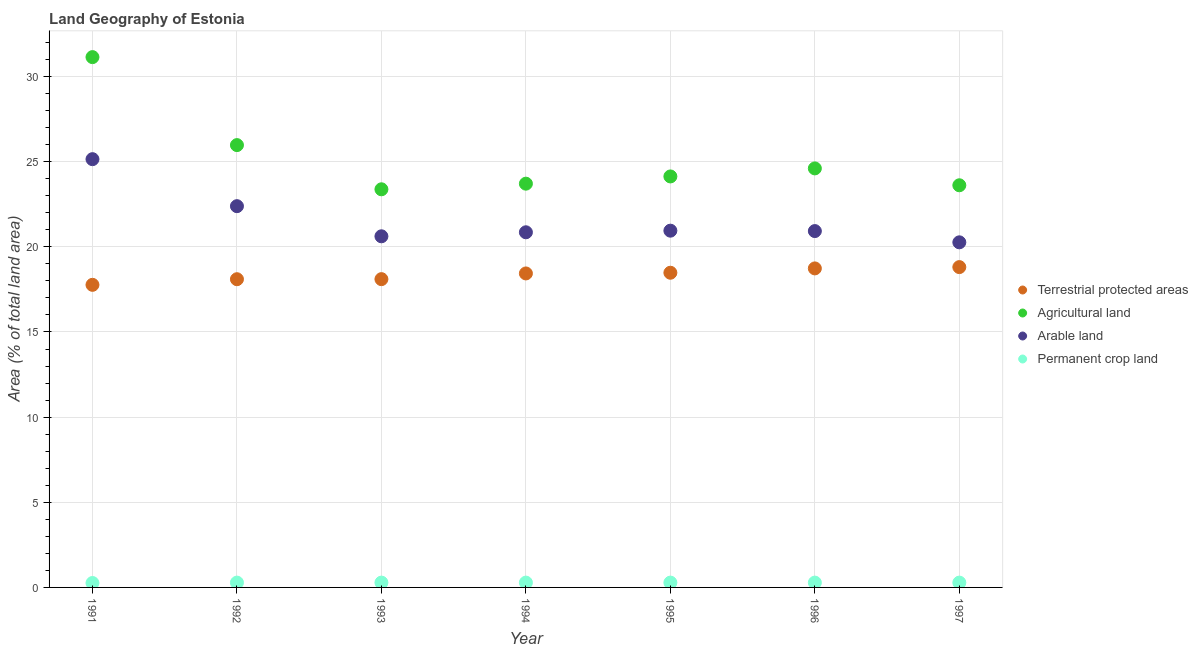What is the percentage of area under agricultural land in 1995?
Offer a very short reply. 24.13. Across all years, what is the maximum percentage of area under arable land?
Ensure brevity in your answer.  25.15. Across all years, what is the minimum percentage of area under agricultural land?
Offer a very short reply. 23.38. In which year was the percentage of area under arable land minimum?
Keep it short and to the point. 1997. What is the total percentage of area under permanent crop land in the graph?
Provide a succinct answer. 1.96. What is the difference between the percentage of land under terrestrial protection in 1993 and that in 1995?
Offer a terse response. -0.38. What is the difference between the percentage of area under permanent crop land in 1994 and the percentage of area under agricultural land in 1993?
Ensure brevity in your answer.  -23.1. What is the average percentage of area under permanent crop land per year?
Your response must be concise. 0.28. In the year 1991, what is the difference between the percentage of area under arable land and percentage of area under permanent crop land?
Offer a very short reply. 24.89. What is the ratio of the percentage of area under agricultural land in 1992 to that in 1993?
Ensure brevity in your answer.  1.11. Is the difference between the percentage of land under terrestrial protection in 1995 and 1997 greater than the difference between the percentage of area under agricultural land in 1995 and 1997?
Provide a short and direct response. No. What is the difference between the highest and the second highest percentage of land under terrestrial protection?
Offer a very short reply. 0.08. What is the difference between the highest and the lowest percentage of area under agricultural land?
Give a very brief answer. 7.76. In how many years, is the percentage of area under agricultural land greater than the average percentage of area under agricultural land taken over all years?
Keep it short and to the point. 2. Is the sum of the percentage of area under permanent crop land in 1992 and 1996 greater than the maximum percentage of area under agricultural land across all years?
Offer a terse response. No. How many years are there in the graph?
Your answer should be compact. 7. Are the values on the major ticks of Y-axis written in scientific E-notation?
Ensure brevity in your answer.  No. Does the graph contain any zero values?
Your answer should be very brief. No. Does the graph contain grids?
Give a very brief answer. Yes. How are the legend labels stacked?
Offer a very short reply. Vertical. What is the title of the graph?
Your response must be concise. Land Geography of Estonia. What is the label or title of the Y-axis?
Provide a succinct answer. Area (% of total land area). What is the Area (% of total land area) in Terrestrial protected areas in 1991?
Provide a short and direct response. 17.77. What is the Area (% of total land area) in Agricultural land in 1991?
Offer a very short reply. 31.14. What is the Area (% of total land area) in Arable land in 1991?
Your answer should be very brief. 25.15. What is the Area (% of total land area) of Permanent crop land in 1991?
Provide a succinct answer. 0.26. What is the Area (% of total land area) in Terrestrial protected areas in 1992?
Provide a succinct answer. 18.1. What is the Area (% of total land area) in Agricultural land in 1992?
Your response must be concise. 25.97. What is the Area (% of total land area) in Arable land in 1992?
Keep it short and to the point. 22.39. What is the Area (% of total land area) of Permanent crop land in 1992?
Provide a succinct answer. 0.28. What is the Area (% of total land area) in Terrestrial protected areas in 1993?
Your answer should be very brief. 18.1. What is the Area (% of total land area) of Agricultural land in 1993?
Make the answer very short. 23.38. What is the Area (% of total land area) of Arable land in 1993?
Provide a succinct answer. 20.62. What is the Area (% of total land area) in Permanent crop land in 1993?
Give a very brief answer. 0.28. What is the Area (% of total land area) in Terrestrial protected areas in 1994?
Give a very brief answer. 18.44. What is the Area (% of total land area) in Agricultural land in 1994?
Give a very brief answer. 23.71. What is the Area (% of total land area) in Arable land in 1994?
Your answer should be very brief. 20.85. What is the Area (% of total land area) of Permanent crop land in 1994?
Your answer should be compact. 0.28. What is the Area (% of total land area) of Terrestrial protected areas in 1995?
Offer a terse response. 18.48. What is the Area (% of total land area) of Agricultural land in 1995?
Your answer should be compact. 24.13. What is the Area (% of total land area) of Arable land in 1995?
Keep it short and to the point. 20.95. What is the Area (% of total land area) in Permanent crop land in 1995?
Offer a very short reply. 0.28. What is the Area (% of total land area) of Terrestrial protected areas in 1996?
Offer a very short reply. 18.73. What is the Area (% of total land area) of Agricultural land in 1996?
Provide a short and direct response. 24.6. What is the Area (% of total land area) in Arable land in 1996?
Your answer should be compact. 20.92. What is the Area (% of total land area) in Permanent crop land in 1996?
Your answer should be compact. 0.28. What is the Area (% of total land area) in Terrestrial protected areas in 1997?
Your answer should be compact. 18.81. What is the Area (% of total land area) of Agricultural land in 1997?
Provide a short and direct response. 23.61. What is the Area (% of total land area) of Arable land in 1997?
Offer a terse response. 20.26. What is the Area (% of total land area) in Permanent crop land in 1997?
Give a very brief answer. 0.28. Across all years, what is the maximum Area (% of total land area) in Terrestrial protected areas?
Give a very brief answer. 18.81. Across all years, what is the maximum Area (% of total land area) of Agricultural land?
Your response must be concise. 31.14. Across all years, what is the maximum Area (% of total land area) of Arable land?
Make the answer very short. 25.15. Across all years, what is the maximum Area (% of total land area) in Permanent crop land?
Your response must be concise. 0.28. Across all years, what is the minimum Area (% of total land area) of Terrestrial protected areas?
Give a very brief answer. 17.77. Across all years, what is the minimum Area (% of total land area) in Agricultural land?
Offer a very short reply. 23.38. Across all years, what is the minimum Area (% of total land area) in Arable land?
Keep it short and to the point. 20.26. Across all years, what is the minimum Area (% of total land area) of Permanent crop land?
Your answer should be very brief. 0.26. What is the total Area (% of total land area) of Terrestrial protected areas in the graph?
Your answer should be compact. 128.43. What is the total Area (% of total land area) in Agricultural land in the graph?
Your answer should be compact. 176.55. What is the total Area (% of total land area) of Arable land in the graph?
Ensure brevity in your answer.  151.14. What is the total Area (% of total land area) of Permanent crop land in the graph?
Offer a very short reply. 1.96. What is the difference between the Area (% of total land area) in Terrestrial protected areas in 1991 and that in 1992?
Provide a short and direct response. -0.33. What is the difference between the Area (% of total land area) of Agricultural land in 1991 and that in 1992?
Provide a short and direct response. 5.17. What is the difference between the Area (% of total land area) in Arable land in 1991 and that in 1992?
Make the answer very short. 2.76. What is the difference between the Area (% of total land area) of Permanent crop land in 1991 and that in 1992?
Your answer should be compact. -0.02. What is the difference between the Area (% of total land area) of Terrestrial protected areas in 1991 and that in 1993?
Provide a short and direct response. -0.33. What is the difference between the Area (% of total land area) in Agricultural land in 1991 and that in 1993?
Make the answer very short. 7.76. What is the difference between the Area (% of total land area) in Arable land in 1991 and that in 1993?
Offer a terse response. 4.53. What is the difference between the Area (% of total land area) of Permanent crop land in 1991 and that in 1993?
Your answer should be very brief. -0.02. What is the difference between the Area (% of total land area) of Terrestrial protected areas in 1991 and that in 1994?
Provide a succinct answer. -0.67. What is the difference between the Area (% of total land area) of Agricultural land in 1991 and that in 1994?
Your answer should be very brief. 7.43. What is the difference between the Area (% of total land area) of Arable land in 1991 and that in 1994?
Provide a short and direct response. 4.29. What is the difference between the Area (% of total land area) in Permanent crop land in 1991 and that in 1994?
Offer a terse response. -0.02. What is the difference between the Area (% of total land area) in Terrestrial protected areas in 1991 and that in 1995?
Your answer should be very brief. -0.71. What is the difference between the Area (% of total land area) in Agricultural land in 1991 and that in 1995?
Give a very brief answer. 7.01. What is the difference between the Area (% of total land area) in Arable land in 1991 and that in 1995?
Offer a terse response. 4.2. What is the difference between the Area (% of total land area) of Permanent crop land in 1991 and that in 1995?
Make the answer very short. -0.02. What is the difference between the Area (% of total land area) in Terrestrial protected areas in 1991 and that in 1996?
Your response must be concise. -0.96. What is the difference between the Area (% of total land area) of Agricultural land in 1991 and that in 1996?
Your answer should be very brief. 6.53. What is the difference between the Area (% of total land area) in Arable land in 1991 and that in 1996?
Your answer should be compact. 4.22. What is the difference between the Area (% of total land area) in Permanent crop land in 1991 and that in 1996?
Give a very brief answer. -0.02. What is the difference between the Area (% of total land area) in Terrestrial protected areas in 1991 and that in 1997?
Make the answer very short. -1.04. What is the difference between the Area (% of total land area) in Agricultural land in 1991 and that in 1997?
Give a very brief answer. 7.53. What is the difference between the Area (% of total land area) of Arable land in 1991 and that in 1997?
Your answer should be very brief. 4.88. What is the difference between the Area (% of total land area) of Permanent crop land in 1991 and that in 1997?
Make the answer very short. -0.02. What is the difference between the Area (% of total land area) in Terrestrial protected areas in 1992 and that in 1993?
Provide a short and direct response. -0. What is the difference between the Area (% of total land area) of Agricultural land in 1992 and that in 1993?
Your answer should be compact. 2.6. What is the difference between the Area (% of total land area) of Arable land in 1992 and that in 1993?
Make the answer very short. 1.77. What is the difference between the Area (% of total land area) of Terrestrial protected areas in 1992 and that in 1994?
Your answer should be very brief. -0.34. What is the difference between the Area (% of total land area) in Agricultural land in 1992 and that in 1994?
Offer a terse response. 2.26. What is the difference between the Area (% of total land area) in Arable land in 1992 and that in 1994?
Provide a succinct answer. 1.53. What is the difference between the Area (% of total land area) in Terrestrial protected areas in 1992 and that in 1995?
Offer a very short reply. -0.38. What is the difference between the Area (% of total land area) of Agricultural land in 1992 and that in 1995?
Provide a short and direct response. 1.84. What is the difference between the Area (% of total land area) in Arable land in 1992 and that in 1995?
Keep it short and to the point. 1.44. What is the difference between the Area (% of total land area) in Terrestrial protected areas in 1992 and that in 1996?
Your answer should be compact. -0.63. What is the difference between the Area (% of total land area) of Agricultural land in 1992 and that in 1996?
Offer a terse response. 1.37. What is the difference between the Area (% of total land area) in Arable land in 1992 and that in 1996?
Offer a very short reply. 1.46. What is the difference between the Area (% of total land area) in Terrestrial protected areas in 1992 and that in 1997?
Keep it short and to the point. -0.71. What is the difference between the Area (% of total land area) in Agricultural land in 1992 and that in 1997?
Your answer should be very brief. 2.36. What is the difference between the Area (% of total land area) of Arable land in 1992 and that in 1997?
Give a very brief answer. 2.12. What is the difference between the Area (% of total land area) in Permanent crop land in 1992 and that in 1997?
Provide a short and direct response. 0. What is the difference between the Area (% of total land area) of Terrestrial protected areas in 1993 and that in 1994?
Offer a very short reply. -0.34. What is the difference between the Area (% of total land area) of Agricultural land in 1993 and that in 1994?
Provide a succinct answer. -0.33. What is the difference between the Area (% of total land area) in Arable land in 1993 and that in 1994?
Ensure brevity in your answer.  -0.24. What is the difference between the Area (% of total land area) in Terrestrial protected areas in 1993 and that in 1995?
Your response must be concise. -0.38. What is the difference between the Area (% of total land area) of Agricultural land in 1993 and that in 1995?
Keep it short and to the point. -0.75. What is the difference between the Area (% of total land area) in Arable land in 1993 and that in 1995?
Offer a terse response. -0.33. What is the difference between the Area (% of total land area) in Terrestrial protected areas in 1993 and that in 1996?
Offer a terse response. -0.63. What is the difference between the Area (% of total land area) in Agricultural land in 1993 and that in 1996?
Make the answer very short. -1.23. What is the difference between the Area (% of total land area) of Arable land in 1993 and that in 1996?
Your answer should be compact. -0.31. What is the difference between the Area (% of total land area) in Terrestrial protected areas in 1993 and that in 1997?
Provide a succinct answer. -0.71. What is the difference between the Area (% of total land area) in Agricultural land in 1993 and that in 1997?
Your answer should be very brief. -0.24. What is the difference between the Area (% of total land area) of Arable land in 1993 and that in 1997?
Ensure brevity in your answer.  0.35. What is the difference between the Area (% of total land area) in Permanent crop land in 1993 and that in 1997?
Make the answer very short. 0. What is the difference between the Area (% of total land area) of Terrestrial protected areas in 1994 and that in 1995?
Your answer should be compact. -0.04. What is the difference between the Area (% of total land area) in Agricultural land in 1994 and that in 1995?
Offer a very short reply. -0.42. What is the difference between the Area (% of total land area) in Arable land in 1994 and that in 1995?
Ensure brevity in your answer.  -0.09. What is the difference between the Area (% of total land area) in Terrestrial protected areas in 1994 and that in 1996?
Make the answer very short. -0.3. What is the difference between the Area (% of total land area) in Agricultural land in 1994 and that in 1996?
Ensure brevity in your answer.  -0.9. What is the difference between the Area (% of total land area) in Arable land in 1994 and that in 1996?
Offer a terse response. -0.07. What is the difference between the Area (% of total land area) in Terrestrial protected areas in 1994 and that in 1997?
Provide a short and direct response. -0.37. What is the difference between the Area (% of total land area) of Agricultural land in 1994 and that in 1997?
Make the answer very short. 0.09. What is the difference between the Area (% of total land area) in Arable land in 1994 and that in 1997?
Your answer should be very brief. 0.59. What is the difference between the Area (% of total land area) in Terrestrial protected areas in 1995 and that in 1996?
Provide a succinct answer. -0.25. What is the difference between the Area (% of total land area) in Agricultural land in 1995 and that in 1996?
Give a very brief answer. -0.47. What is the difference between the Area (% of total land area) in Arable land in 1995 and that in 1996?
Your response must be concise. 0.02. What is the difference between the Area (% of total land area) of Terrestrial protected areas in 1995 and that in 1997?
Your response must be concise. -0.33. What is the difference between the Area (% of total land area) in Agricultural land in 1995 and that in 1997?
Offer a very short reply. 0.52. What is the difference between the Area (% of total land area) of Arable land in 1995 and that in 1997?
Your response must be concise. 0.68. What is the difference between the Area (% of total land area) in Terrestrial protected areas in 1996 and that in 1997?
Your answer should be compact. -0.08. What is the difference between the Area (% of total land area) in Agricultural land in 1996 and that in 1997?
Offer a terse response. 0.99. What is the difference between the Area (% of total land area) in Arable land in 1996 and that in 1997?
Make the answer very short. 0.66. What is the difference between the Area (% of total land area) in Terrestrial protected areas in 1991 and the Area (% of total land area) in Agricultural land in 1992?
Make the answer very short. -8.21. What is the difference between the Area (% of total land area) of Terrestrial protected areas in 1991 and the Area (% of total land area) of Arable land in 1992?
Your answer should be very brief. -4.62. What is the difference between the Area (% of total land area) in Terrestrial protected areas in 1991 and the Area (% of total land area) in Permanent crop land in 1992?
Provide a succinct answer. 17.48. What is the difference between the Area (% of total land area) in Agricultural land in 1991 and the Area (% of total land area) in Arable land in 1992?
Give a very brief answer. 8.75. What is the difference between the Area (% of total land area) in Agricultural land in 1991 and the Area (% of total land area) in Permanent crop land in 1992?
Offer a terse response. 30.86. What is the difference between the Area (% of total land area) in Arable land in 1991 and the Area (% of total land area) in Permanent crop land in 1992?
Offer a very short reply. 24.86. What is the difference between the Area (% of total land area) in Terrestrial protected areas in 1991 and the Area (% of total land area) in Agricultural land in 1993?
Provide a succinct answer. -5.61. What is the difference between the Area (% of total land area) in Terrestrial protected areas in 1991 and the Area (% of total land area) in Arable land in 1993?
Your answer should be very brief. -2.85. What is the difference between the Area (% of total land area) in Terrestrial protected areas in 1991 and the Area (% of total land area) in Permanent crop land in 1993?
Offer a very short reply. 17.48. What is the difference between the Area (% of total land area) of Agricultural land in 1991 and the Area (% of total land area) of Arable land in 1993?
Give a very brief answer. 10.52. What is the difference between the Area (% of total land area) of Agricultural land in 1991 and the Area (% of total land area) of Permanent crop land in 1993?
Make the answer very short. 30.86. What is the difference between the Area (% of total land area) of Arable land in 1991 and the Area (% of total land area) of Permanent crop land in 1993?
Make the answer very short. 24.86. What is the difference between the Area (% of total land area) of Terrestrial protected areas in 1991 and the Area (% of total land area) of Agricultural land in 1994?
Your answer should be very brief. -5.94. What is the difference between the Area (% of total land area) of Terrestrial protected areas in 1991 and the Area (% of total land area) of Arable land in 1994?
Give a very brief answer. -3.09. What is the difference between the Area (% of total land area) of Terrestrial protected areas in 1991 and the Area (% of total land area) of Permanent crop land in 1994?
Offer a very short reply. 17.48. What is the difference between the Area (% of total land area) in Agricultural land in 1991 and the Area (% of total land area) in Arable land in 1994?
Offer a terse response. 10.29. What is the difference between the Area (% of total land area) of Agricultural land in 1991 and the Area (% of total land area) of Permanent crop land in 1994?
Make the answer very short. 30.86. What is the difference between the Area (% of total land area) of Arable land in 1991 and the Area (% of total land area) of Permanent crop land in 1994?
Your answer should be compact. 24.86. What is the difference between the Area (% of total land area) of Terrestrial protected areas in 1991 and the Area (% of total land area) of Agricultural land in 1995?
Your answer should be very brief. -6.37. What is the difference between the Area (% of total land area) of Terrestrial protected areas in 1991 and the Area (% of total land area) of Arable land in 1995?
Provide a short and direct response. -3.18. What is the difference between the Area (% of total land area) of Terrestrial protected areas in 1991 and the Area (% of total land area) of Permanent crop land in 1995?
Offer a very short reply. 17.48. What is the difference between the Area (% of total land area) of Agricultural land in 1991 and the Area (% of total land area) of Arable land in 1995?
Your response must be concise. 10.19. What is the difference between the Area (% of total land area) in Agricultural land in 1991 and the Area (% of total land area) in Permanent crop land in 1995?
Your answer should be very brief. 30.86. What is the difference between the Area (% of total land area) in Arable land in 1991 and the Area (% of total land area) in Permanent crop land in 1995?
Your answer should be very brief. 24.86. What is the difference between the Area (% of total land area) in Terrestrial protected areas in 1991 and the Area (% of total land area) in Agricultural land in 1996?
Your response must be concise. -6.84. What is the difference between the Area (% of total land area) in Terrestrial protected areas in 1991 and the Area (% of total land area) in Arable land in 1996?
Your response must be concise. -3.16. What is the difference between the Area (% of total land area) in Terrestrial protected areas in 1991 and the Area (% of total land area) in Permanent crop land in 1996?
Your response must be concise. 17.48. What is the difference between the Area (% of total land area) of Agricultural land in 1991 and the Area (% of total land area) of Arable land in 1996?
Provide a short and direct response. 10.21. What is the difference between the Area (% of total land area) in Agricultural land in 1991 and the Area (% of total land area) in Permanent crop land in 1996?
Provide a succinct answer. 30.86. What is the difference between the Area (% of total land area) in Arable land in 1991 and the Area (% of total land area) in Permanent crop land in 1996?
Provide a short and direct response. 24.86. What is the difference between the Area (% of total land area) of Terrestrial protected areas in 1991 and the Area (% of total land area) of Agricultural land in 1997?
Make the answer very short. -5.85. What is the difference between the Area (% of total land area) of Terrestrial protected areas in 1991 and the Area (% of total land area) of Arable land in 1997?
Provide a short and direct response. -2.5. What is the difference between the Area (% of total land area) in Terrestrial protected areas in 1991 and the Area (% of total land area) in Permanent crop land in 1997?
Offer a terse response. 17.48. What is the difference between the Area (% of total land area) of Agricultural land in 1991 and the Area (% of total land area) of Arable land in 1997?
Provide a short and direct response. 10.88. What is the difference between the Area (% of total land area) of Agricultural land in 1991 and the Area (% of total land area) of Permanent crop land in 1997?
Keep it short and to the point. 30.86. What is the difference between the Area (% of total land area) in Arable land in 1991 and the Area (% of total land area) in Permanent crop land in 1997?
Your answer should be very brief. 24.86. What is the difference between the Area (% of total land area) of Terrestrial protected areas in 1992 and the Area (% of total land area) of Agricultural land in 1993?
Offer a terse response. -5.28. What is the difference between the Area (% of total land area) of Terrestrial protected areas in 1992 and the Area (% of total land area) of Arable land in 1993?
Offer a terse response. -2.52. What is the difference between the Area (% of total land area) in Terrestrial protected areas in 1992 and the Area (% of total land area) in Permanent crop land in 1993?
Ensure brevity in your answer.  17.82. What is the difference between the Area (% of total land area) in Agricultural land in 1992 and the Area (% of total land area) in Arable land in 1993?
Your answer should be very brief. 5.36. What is the difference between the Area (% of total land area) of Agricultural land in 1992 and the Area (% of total land area) of Permanent crop land in 1993?
Provide a succinct answer. 25.69. What is the difference between the Area (% of total land area) of Arable land in 1992 and the Area (% of total land area) of Permanent crop land in 1993?
Your response must be concise. 22.1. What is the difference between the Area (% of total land area) in Terrestrial protected areas in 1992 and the Area (% of total land area) in Agricultural land in 1994?
Provide a short and direct response. -5.61. What is the difference between the Area (% of total land area) in Terrestrial protected areas in 1992 and the Area (% of total land area) in Arable land in 1994?
Make the answer very short. -2.76. What is the difference between the Area (% of total land area) in Terrestrial protected areas in 1992 and the Area (% of total land area) in Permanent crop land in 1994?
Ensure brevity in your answer.  17.82. What is the difference between the Area (% of total land area) of Agricultural land in 1992 and the Area (% of total land area) of Arable land in 1994?
Provide a short and direct response. 5.12. What is the difference between the Area (% of total land area) of Agricultural land in 1992 and the Area (% of total land area) of Permanent crop land in 1994?
Offer a very short reply. 25.69. What is the difference between the Area (% of total land area) of Arable land in 1992 and the Area (% of total land area) of Permanent crop land in 1994?
Keep it short and to the point. 22.1. What is the difference between the Area (% of total land area) in Terrestrial protected areas in 1992 and the Area (% of total land area) in Agricultural land in 1995?
Make the answer very short. -6.03. What is the difference between the Area (% of total land area) in Terrestrial protected areas in 1992 and the Area (% of total land area) in Arable land in 1995?
Your response must be concise. -2.85. What is the difference between the Area (% of total land area) of Terrestrial protected areas in 1992 and the Area (% of total land area) of Permanent crop land in 1995?
Give a very brief answer. 17.82. What is the difference between the Area (% of total land area) in Agricultural land in 1992 and the Area (% of total land area) in Arable land in 1995?
Your response must be concise. 5.02. What is the difference between the Area (% of total land area) in Agricultural land in 1992 and the Area (% of total land area) in Permanent crop land in 1995?
Make the answer very short. 25.69. What is the difference between the Area (% of total land area) in Arable land in 1992 and the Area (% of total land area) in Permanent crop land in 1995?
Provide a short and direct response. 22.1. What is the difference between the Area (% of total land area) in Terrestrial protected areas in 1992 and the Area (% of total land area) in Agricultural land in 1996?
Offer a terse response. -6.51. What is the difference between the Area (% of total land area) in Terrestrial protected areas in 1992 and the Area (% of total land area) in Arable land in 1996?
Provide a succinct answer. -2.83. What is the difference between the Area (% of total land area) of Terrestrial protected areas in 1992 and the Area (% of total land area) of Permanent crop land in 1996?
Provide a succinct answer. 17.82. What is the difference between the Area (% of total land area) in Agricultural land in 1992 and the Area (% of total land area) in Arable land in 1996?
Provide a short and direct response. 5.05. What is the difference between the Area (% of total land area) of Agricultural land in 1992 and the Area (% of total land area) of Permanent crop land in 1996?
Offer a terse response. 25.69. What is the difference between the Area (% of total land area) in Arable land in 1992 and the Area (% of total land area) in Permanent crop land in 1996?
Ensure brevity in your answer.  22.1. What is the difference between the Area (% of total land area) in Terrestrial protected areas in 1992 and the Area (% of total land area) in Agricultural land in 1997?
Your response must be concise. -5.52. What is the difference between the Area (% of total land area) in Terrestrial protected areas in 1992 and the Area (% of total land area) in Arable land in 1997?
Your answer should be very brief. -2.17. What is the difference between the Area (% of total land area) in Terrestrial protected areas in 1992 and the Area (% of total land area) in Permanent crop land in 1997?
Ensure brevity in your answer.  17.82. What is the difference between the Area (% of total land area) of Agricultural land in 1992 and the Area (% of total land area) of Arable land in 1997?
Offer a terse response. 5.71. What is the difference between the Area (% of total land area) of Agricultural land in 1992 and the Area (% of total land area) of Permanent crop land in 1997?
Offer a terse response. 25.69. What is the difference between the Area (% of total land area) of Arable land in 1992 and the Area (% of total land area) of Permanent crop land in 1997?
Offer a terse response. 22.1. What is the difference between the Area (% of total land area) of Terrestrial protected areas in 1993 and the Area (% of total land area) of Agricultural land in 1994?
Offer a terse response. -5.61. What is the difference between the Area (% of total land area) of Terrestrial protected areas in 1993 and the Area (% of total land area) of Arable land in 1994?
Offer a very short reply. -2.75. What is the difference between the Area (% of total land area) in Terrestrial protected areas in 1993 and the Area (% of total land area) in Permanent crop land in 1994?
Ensure brevity in your answer.  17.82. What is the difference between the Area (% of total land area) of Agricultural land in 1993 and the Area (% of total land area) of Arable land in 1994?
Keep it short and to the point. 2.52. What is the difference between the Area (% of total land area) in Agricultural land in 1993 and the Area (% of total land area) in Permanent crop land in 1994?
Offer a very short reply. 23.1. What is the difference between the Area (% of total land area) in Arable land in 1993 and the Area (% of total land area) in Permanent crop land in 1994?
Your answer should be compact. 20.34. What is the difference between the Area (% of total land area) in Terrestrial protected areas in 1993 and the Area (% of total land area) in Agricultural land in 1995?
Offer a terse response. -6.03. What is the difference between the Area (% of total land area) of Terrestrial protected areas in 1993 and the Area (% of total land area) of Arable land in 1995?
Provide a succinct answer. -2.85. What is the difference between the Area (% of total land area) of Terrestrial protected areas in 1993 and the Area (% of total land area) of Permanent crop land in 1995?
Your answer should be compact. 17.82. What is the difference between the Area (% of total land area) in Agricultural land in 1993 and the Area (% of total land area) in Arable land in 1995?
Keep it short and to the point. 2.43. What is the difference between the Area (% of total land area) in Agricultural land in 1993 and the Area (% of total land area) in Permanent crop land in 1995?
Offer a terse response. 23.1. What is the difference between the Area (% of total land area) in Arable land in 1993 and the Area (% of total land area) in Permanent crop land in 1995?
Your answer should be very brief. 20.34. What is the difference between the Area (% of total land area) in Terrestrial protected areas in 1993 and the Area (% of total land area) in Agricultural land in 1996?
Make the answer very short. -6.5. What is the difference between the Area (% of total land area) of Terrestrial protected areas in 1993 and the Area (% of total land area) of Arable land in 1996?
Make the answer very short. -2.82. What is the difference between the Area (% of total land area) in Terrestrial protected areas in 1993 and the Area (% of total land area) in Permanent crop land in 1996?
Your response must be concise. 17.82. What is the difference between the Area (% of total land area) in Agricultural land in 1993 and the Area (% of total land area) in Arable land in 1996?
Keep it short and to the point. 2.45. What is the difference between the Area (% of total land area) of Agricultural land in 1993 and the Area (% of total land area) of Permanent crop land in 1996?
Your response must be concise. 23.1. What is the difference between the Area (% of total land area) in Arable land in 1993 and the Area (% of total land area) in Permanent crop land in 1996?
Your answer should be compact. 20.34. What is the difference between the Area (% of total land area) of Terrestrial protected areas in 1993 and the Area (% of total land area) of Agricultural land in 1997?
Your answer should be compact. -5.51. What is the difference between the Area (% of total land area) of Terrestrial protected areas in 1993 and the Area (% of total land area) of Arable land in 1997?
Provide a short and direct response. -2.16. What is the difference between the Area (% of total land area) in Terrestrial protected areas in 1993 and the Area (% of total land area) in Permanent crop land in 1997?
Your answer should be compact. 17.82. What is the difference between the Area (% of total land area) of Agricultural land in 1993 and the Area (% of total land area) of Arable land in 1997?
Ensure brevity in your answer.  3.11. What is the difference between the Area (% of total land area) in Agricultural land in 1993 and the Area (% of total land area) in Permanent crop land in 1997?
Provide a succinct answer. 23.1. What is the difference between the Area (% of total land area) of Arable land in 1993 and the Area (% of total land area) of Permanent crop land in 1997?
Your response must be concise. 20.34. What is the difference between the Area (% of total land area) in Terrestrial protected areas in 1994 and the Area (% of total land area) in Agricultural land in 1995?
Offer a terse response. -5.7. What is the difference between the Area (% of total land area) in Terrestrial protected areas in 1994 and the Area (% of total land area) in Arable land in 1995?
Make the answer very short. -2.51. What is the difference between the Area (% of total land area) in Terrestrial protected areas in 1994 and the Area (% of total land area) in Permanent crop land in 1995?
Give a very brief answer. 18.15. What is the difference between the Area (% of total land area) of Agricultural land in 1994 and the Area (% of total land area) of Arable land in 1995?
Keep it short and to the point. 2.76. What is the difference between the Area (% of total land area) of Agricultural land in 1994 and the Area (% of total land area) of Permanent crop land in 1995?
Offer a very short reply. 23.43. What is the difference between the Area (% of total land area) in Arable land in 1994 and the Area (% of total land area) in Permanent crop land in 1995?
Offer a terse response. 20.57. What is the difference between the Area (% of total land area) of Terrestrial protected areas in 1994 and the Area (% of total land area) of Agricultural land in 1996?
Ensure brevity in your answer.  -6.17. What is the difference between the Area (% of total land area) of Terrestrial protected areas in 1994 and the Area (% of total land area) of Arable land in 1996?
Make the answer very short. -2.49. What is the difference between the Area (% of total land area) in Terrestrial protected areas in 1994 and the Area (% of total land area) in Permanent crop land in 1996?
Provide a short and direct response. 18.15. What is the difference between the Area (% of total land area) of Agricultural land in 1994 and the Area (% of total land area) of Arable land in 1996?
Offer a terse response. 2.78. What is the difference between the Area (% of total land area) of Agricultural land in 1994 and the Area (% of total land area) of Permanent crop land in 1996?
Offer a very short reply. 23.43. What is the difference between the Area (% of total land area) of Arable land in 1994 and the Area (% of total land area) of Permanent crop land in 1996?
Provide a short and direct response. 20.57. What is the difference between the Area (% of total land area) of Terrestrial protected areas in 1994 and the Area (% of total land area) of Agricultural land in 1997?
Give a very brief answer. -5.18. What is the difference between the Area (% of total land area) of Terrestrial protected areas in 1994 and the Area (% of total land area) of Arable land in 1997?
Make the answer very short. -1.83. What is the difference between the Area (% of total land area) in Terrestrial protected areas in 1994 and the Area (% of total land area) in Permanent crop land in 1997?
Provide a succinct answer. 18.15. What is the difference between the Area (% of total land area) of Agricultural land in 1994 and the Area (% of total land area) of Arable land in 1997?
Your answer should be compact. 3.44. What is the difference between the Area (% of total land area) of Agricultural land in 1994 and the Area (% of total land area) of Permanent crop land in 1997?
Ensure brevity in your answer.  23.43. What is the difference between the Area (% of total land area) of Arable land in 1994 and the Area (% of total land area) of Permanent crop land in 1997?
Provide a short and direct response. 20.57. What is the difference between the Area (% of total land area) of Terrestrial protected areas in 1995 and the Area (% of total land area) of Agricultural land in 1996?
Provide a short and direct response. -6.13. What is the difference between the Area (% of total land area) of Terrestrial protected areas in 1995 and the Area (% of total land area) of Arable land in 1996?
Make the answer very short. -2.45. What is the difference between the Area (% of total land area) in Terrestrial protected areas in 1995 and the Area (% of total land area) in Permanent crop land in 1996?
Offer a terse response. 18.2. What is the difference between the Area (% of total land area) in Agricultural land in 1995 and the Area (% of total land area) in Arable land in 1996?
Offer a very short reply. 3.21. What is the difference between the Area (% of total land area) of Agricultural land in 1995 and the Area (% of total land area) of Permanent crop land in 1996?
Make the answer very short. 23.85. What is the difference between the Area (% of total land area) in Arable land in 1995 and the Area (% of total land area) in Permanent crop land in 1996?
Make the answer very short. 20.67. What is the difference between the Area (% of total land area) in Terrestrial protected areas in 1995 and the Area (% of total land area) in Agricultural land in 1997?
Provide a succinct answer. -5.14. What is the difference between the Area (% of total land area) of Terrestrial protected areas in 1995 and the Area (% of total land area) of Arable land in 1997?
Ensure brevity in your answer.  -1.79. What is the difference between the Area (% of total land area) of Terrestrial protected areas in 1995 and the Area (% of total land area) of Permanent crop land in 1997?
Offer a very short reply. 18.2. What is the difference between the Area (% of total land area) in Agricultural land in 1995 and the Area (% of total land area) in Arable land in 1997?
Make the answer very short. 3.87. What is the difference between the Area (% of total land area) in Agricultural land in 1995 and the Area (% of total land area) in Permanent crop land in 1997?
Give a very brief answer. 23.85. What is the difference between the Area (% of total land area) of Arable land in 1995 and the Area (% of total land area) of Permanent crop land in 1997?
Provide a succinct answer. 20.67. What is the difference between the Area (% of total land area) of Terrestrial protected areas in 1996 and the Area (% of total land area) of Agricultural land in 1997?
Your response must be concise. -4.88. What is the difference between the Area (% of total land area) in Terrestrial protected areas in 1996 and the Area (% of total land area) in Arable land in 1997?
Make the answer very short. -1.53. What is the difference between the Area (% of total land area) in Terrestrial protected areas in 1996 and the Area (% of total land area) in Permanent crop land in 1997?
Offer a very short reply. 18.45. What is the difference between the Area (% of total land area) of Agricultural land in 1996 and the Area (% of total land area) of Arable land in 1997?
Your answer should be compact. 4.34. What is the difference between the Area (% of total land area) in Agricultural land in 1996 and the Area (% of total land area) in Permanent crop land in 1997?
Offer a terse response. 24.32. What is the difference between the Area (% of total land area) of Arable land in 1996 and the Area (% of total land area) of Permanent crop land in 1997?
Provide a short and direct response. 20.64. What is the average Area (% of total land area) in Terrestrial protected areas per year?
Keep it short and to the point. 18.35. What is the average Area (% of total land area) in Agricultural land per year?
Your answer should be compact. 25.22. What is the average Area (% of total land area) of Arable land per year?
Your response must be concise. 21.59. What is the average Area (% of total land area) of Permanent crop land per year?
Your answer should be compact. 0.28. In the year 1991, what is the difference between the Area (% of total land area) of Terrestrial protected areas and Area (% of total land area) of Agricultural land?
Offer a terse response. -13.37. In the year 1991, what is the difference between the Area (% of total land area) of Terrestrial protected areas and Area (% of total land area) of Arable land?
Provide a succinct answer. -7.38. In the year 1991, what is the difference between the Area (% of total land area) of Terrestrial protected areas and Area (% of total land area) of Permanent crop land?
Offer a terse response. 17.51. In the year 1991, what is the difference between the Area (% of total land area) of Agricultural land and Area (% of total land area) of Arable land?
Ensure brevity in your answer.  5.99. In the year 1991, what is the difference between the Area (% of total land area) of Agricultural land and Area (% of total land area) of Permanent crop land?
Offer a terse response. 30.88. In the year 1991, what is the difference between the Area (% of total land area) in Arable land and Area (% of total land area) in Permanent crop land?
Offer a terse response. 24.89. In the year 1992, what is the difference between the Area (% of total land area) in Terrestrial protected areas and Area (% of total land area) in Agricultural land?
Provide a short and direct response. -7.87. In the year 1992, what is the difference between the Area (% of total land area) of Terrestrial protected areas and Area (% of total land area) of Arable land?
Offer a terse response. -4.29. In the year 1992, what is the difference between the Area (% of total land area) in Terrestrial protected areas and Area (% of total land area) in Permanent crop land?
Keep it short and to the point. 17.82. In the year 1992, what is the difference between the Area (% of total land area) of Agricultural land and Area (% of total land area) of Arable land?
Make the answer very short. 3.59. In the year 1992, what is the difference between the Area (% of total land area) of Agricultural land and Area (% of total land area) of Permanent crop land?
Give a very brief answer. 25.69. In the year 1992, what is the difference between the Area (% of total land area) of Arable land and Area (% of total land area) of Permanent crop land?
Ensure brevity in your answer.  22.1. In the year 1993, what is the difference between the Area (% of total land area) of Terrestrial protected areas and Area (% of total land area) of Agricultural land?
Give a very brief answer. -5.28. In the year 1993, what is the difference between the Area (% of total land area) in Terrestrial protected areas and Area (% of total land area) in Arable land?
Ensure brevity in your answer.  -2.52. In the year 1993, what is the difference between the Area (% of total land area) of Terrestrial protected areas and Area (% of total land area) of Permanent crop land?
Offer a terse response. 17.82. In the year 1993, what is the difference between the Area (% of total land area) of Agricultural land and Area (% of total land area) of Arable land?
Your response must be concise. 2.76. In the year 1993, what is the difference between the Area (% of total land area) in Agricultural land and Area (% of total land area) in Permanent crop land?
Your answer should be compact. 23.1. In the year 1993, what is the difference between the Area (% of total land area) in Arable land and Area (% of total land area) in Permanent crop land?
Your answer should be very brief. 20.34. In the year 1994, what is the difference between the Area (% of total land area) of Terrestrial protected areas and Area (% of total land area) of Agricultural land?
Your answer should be compact. -5.27. In the year 1994, what is the difference between the Area (% of total land area) in Terrestrial protected areas and Area (% of total land area) in Arable land?
Your answer should be very brief. -2.42. In the year 1994, what is the difference between the Area (% of total land area) of Terrestrial protected areas and Area (% of total land area) of Permanent crop land?
Your response must be concise. 18.15. In the year 1994, what is the difference between the Area (% of total land area) in Agricultural land and Area (% of total land area) in Arable land?
Your answer should be very brief. 2.85. In the year 1994, what is the difference between the Area (% of total land area) in Agricultural land and Area (% of total land area) in Permanent crop land?
Your answer should be compact. 23.43. In the year 1994, what is the difference between the Area (% of total land area) of Arable land and Area (% of total land area) of Permanent crop land?
Give a very brief answer. 20.57. In the year 1995, what is the difference between the Area (% of total land area) of Terrestrial protected areas and Area (% of total land area) of Agricultural land?
Your response must be concise. -5.65. In the year 1995, what is the difference between the Area (% of total land area) in Terrestrial protected areas and Area (% of total land area) in Arable land?
Your answer should be compact. -2.47. In the year 1995, what is the difference between the Area (% of total land area) in Terrestrial protected areas and Area (% of total land area) in Permanent crop land?
Your answer should be very brief. 18.2. In the year 1995, what is the difference between the Area (% of total land area) of Agricultural land and Area (% of total land area) of Arable land?
Your response must be concise. 3.18. In the year 1995, what is the difference between the Area (% of total land area) in Agricultural land and Area (% of total land area) in Permanent crop land?
Offer a terse response. 23.85. In the year 1995, what is the difference between the Area (% of total land area) in Arable land and Area (% of total land area) in Permanent crop land?
Provide a short and direct response. 20.67. In the year 1996, what is the difference between the Area (% of total land area) in Terrestrial protected areas and Area (% of total land area) in Agricultural land?
Your answer should be very brief. -5.87. In the year 1996, what is the difference between the Area (% of total land area) of Terrestrial protected areas and Area (% of total land area) of Arable land?
Ensure brevity in your answer.  -2.19. In the year 1996, what is the difference between the Area (% of total land area) in Terrestrial protected areas and Area (% of total land area) in Permanent crop land?
Keep it short and to the point. 18.45. In the year 1996, what is the difference between the Area (% of total land area) of Agricultural land and Area (% of total land area) of Arable land?
Make the answer very short. 3.68. In the year 1996, what is the difference between the Area (% of total land area) of Agricultural land and Area (% of total land area) of Permanent crop land?
Your response must be concise. 24.32. In the year 1996, what is the difference between the Area (% of total land area) in Arable land and Area (% of total land area) in Permanent crop land?
Make the answer very short. 20.64. In the year 1997, what is the difference between the Area (% of total land area) in Terrestrial protected areas and Area (% of total land area) in Agricultural land?
Keep it short and to the point. -4.8. In the year 1997, what is the difference between the Area (% of total land area) of Terrestrial protected areas and Area (% of total land area) of Arable land?
Keep it short and to the point. -1.45. In the year 1997, what is the difference between the Area (% of total land area) in Terrestrial protected areas and Area (% of total land area) in Permanent crop land?
Your answer should be compact. 18.53. In the year 1997, what is the difference between the Area (% of total land area) in Agricultural land and Area (% of total land area) in Arable land?
Your answer should be very brief. 3.35. In the year 1997, what is the difference between the Area (% of total land area) of Agricultural land and Area (% of total land area) of Permanent crop land?
Give a very brief answer. 23.33. In the year 1997, what is the difference between the Area (% of total land area) of Arable land and Area (% of total land area) of Permanent crop land?
Your answer should be very brief. 19.98. What is the ratio of the Area (% of total land area) of Terrestrial protected areas in 1991 to that in 1992?
Make the answer very short. 0.98. What is the ratio of the Area (% of total land area) of Agricultural land in 1991 to that in 1992?
Make the answer very short. 1.2. What is the ratio of the Area (% of total land area) in Arable land in 1991 to that in 1992?
Your response must be concise. 1.12. What is the ratio of the Area (% of total land area) in Permanent crop land in 1991 to that in 1992?
Provide a succinct answer. 0.92. What is the ratio of the Area (% of total land area) of Terrestrial protected areas in 1991 to that in 1993?
Offer a terse response. 0.98. What is the ratio of the Area (% of total land area) of Agricultural land in 1991 to that in 1993?
Your response must be concise. 1.33. What is the ratio of the Area (% of total land area) in Arable land in 1991 to that in 1993?
Your response must be concise. 1.22. What is the ratio of the Area (% of total land area) of Permanent crop land in 1991 to that in 1993?
Give a very brief answer. 0.92. What is the ratio of the Area (% of total land area) in Terrestrial protected areas in 1991 to that in 1994?
Offer a terse response. 0.96. What is the ratio of the Area (% of total land area) in Agricultural land in 1991 to that in 1994?
Your answer should be very brief. 1.31. What is the ratio of the Area (% of total land area) of Arable land in 1991 to that in 1994?
Your answer should be compact. 1.21. What is the ratio of the Area (% of total land area) in Permanent crop land in 1991 to that in 1994?
Provide a succinct answer. 0.92. What is the ratio of the Area (% of total land area) in Terrestrial protected areas in 1991 to that in 1995?
Your response must be concise. 0.96. What is the ratio of the Area (% of total land area) in Agricultural land in 1991 to that in 1995?
Offer a very short reply. 1.29. What is the ratio of the Area (% of total land area) of Arable land in 1991 to that in 1995?
Ensure brevity in your answer.  1.2. What is the ratio of the Area (% of total land area) of Permanent crop land in 1991 to that in 1995?
Ensure brevity in your answer.  0.92. What is the ratio of the Area (% of total land area) in Terrestrial protected areas in 1991 to that in 1996?
Provide a short and direct response. 0.95. What is the ratio of the Area (% of total land area) of Agricultural land in 1991 to that in 1996?
Offer a very short reply. 1.27. What is the ratio of the Area (% of total land area) of Arable land in 1991 to that in 1996?
Your answer should be very brief. 1.2. What is the ratio of the Area (% of total land area) in Permanent crop land in 1991 to that in 1996?
Your answer should be compact. 0.92. What is the ratio of the Area (% of total land area) in Terrestrial protected areas in 1991 to that in 1997?
Your response must be concise. 0.94. What is the ratio of the Area (% of total land area) of Agricultural land in 1991 to that in 1997?
Provide a short and direct response. 1.32. What is the ratio of the Area (% of total land area) in Arable land in 1991 to that in 1997?
Provide a short and direct response. 1.24. What is the ratio of the Area (% of total land area) in Permanent crop land in 1991 to that in 1997?
Offer a very short reply. 0.92. What is the ratio of the Area (% of total land area) in Terrestrial protected areas in 1992 to that in 1993?
Offer a very short reply. 1. What is the ratio of the Area (% of total land area) in Agricultural land in 1992 to that in 1993?
Your response must be concise. 1.11. What is the ratio of the Area (% of total land area) of Arable land in 1992 to that in 1993?
Offer a terse response. 1.09. What is the ratio of the Area (% of total land area) in Terrestrial protected areas in 1992 to that in 1994?
Provide a succinct answer. 0.98. What is the ratio of the Area (% of total land area) in Agricultural land in 1992 to that in 1994?
Provide a succinct answer. 1.1. What is the ratio of the Area (% of total land area) of Arable land in 1992 to that in 1994?
Offer a very short reply. 1.07. What is the ratio of the Area (% of total land area) of Permanent crop land in 1992 to that in 1994?
Make the answer very short. 1. What is the ratio of the Area (% of total land area) of Terrestrial protected areas in 1992 to that in 1995?
Give a very brief answer. 0.98. What is the ratio of the Area (% of total land area) in Agricultural land in 1992 to that in 1995?
Provide a short and direct response. 1.08. What is the ratio of the Area (% of total land area) of Arable land in 1992 to that in 1995?
Give a very brief answer. 1.07. What is the ratio of the Area (% of total land area) in Permanent crop land in 1992 to that in 1995?
Your answer should be very brief. 1. What is the ratio of the Area (% of total land area) of Terrestrial protected areas in 1992 to that in 1996?
Ensure brevity in your answer.  0.97. What is the ratio of the Area (% of total land area) in Agricultural land in 1992 to that in 1996?
Make the answer very short. 1.06. What is the ratio of the Area (% of total land area) of Arable land in 1992 to that in 1996?
Your answer should be compact. 1.07. What is the ratio of the Area (% of total land area) of Permanent crop land in 1992 to that in 1996?
Offer a terse response. 1. What is the ratio of the Area (% of total land area) in Terrestrial protected areas in 1992 to that in 1997?
Your response must be concise. 0.96. What is the ratio of the Area (% of total land area) in Agricultural land in 1992 to that in 1997?
Give a very brief answer. 1.1. What is the ratio of the Area (% of total land area) of Arable land in 1992 to that in 1997?
Offer a terse response. 1.1. What is the ratio of the Area (% of total land area) of Terrestrial protected areas in 1993 to that in 1994?
Your answer should be very brief. 0.98. What is the ratio of the Area (% of total land area) in Agricultural land in 1993 to that in 1994?
Offer a very short reply. 0.99. What is the ratio of the Area (% of total land area) of Arable land in 1993 to that in 1994?
Provide a short and direct response. 0.99. What is the ratio of the Area (% of total land area) in Permanent crop land in 1993 to that in 1994?
Your answer should be very brief. 1. What is the ratio of the Area (% of total land area) in Terrestrial protected areas in 1993 to that in 1995?
Ensure brevity in your answer.  0.98. What is the ratio of the Area (% of total land area) of Agricultural land in 1993 to that in 1995?
Ensure brevity in your answer.  0.97. What is the ratio of the Area (% of total land area) in Arable land in 1993 to that in 1995?
Provide a short and direct response. 0.98. What is the ratio of the Area (% of total land area) of Permanent crop land in 1993 to that in 1995?
Offer a very short reply. 1. What is the ratio of the Area (% of total land area) in Terrestrial protected areas in 1993 to that in 1996?
Provide a short and direct response. 0.97. What is the ratio of the Area (% of total land area) of Agricultural land in 1993 to that in 1996?
Provide a short and direct response. 0.95. What is the ratio of the Area (% of total land area) in Permanent crop land in 1993 to that in 1996?
Offer a terse response. 1. What is the ratio of the Area (% of total land area) in Terrestrial protected areas in 1993 to that in 1997?
Keep it short and to the point. 0.96. What is the ratio of the Area (% of total land area) in Agricultural land in 1993 to that in 1997?
Offer a very short reply. 0.99. What is the ratio of the Area (% of total land area) in Arable land in 1993 to that in 1997?
Your answer should be compact. 1.02. What is the ratio of the Area (% of total land area) of Permanent crop land in 1993 to that in 1997?
Give a very brief answer. 1. What is the ratio of the Area (% of total land area) in Terrestrial protected areas in 1994 to that in 1995?
Give a very brief answer. 1. What is the ratio of the Area (% of total land area) in Agricultural land in 1994 to that in 1995?
Provide a short and direct response. 0.98. What is the ratio of the Area (% of total land area) in Terrestrial protected areas in 1994 to that in 1996?
Make the answer very short. 0.98. What is the ratio of the Area (% of total land area) of Agricultural land in 1994 to that in 1996?
Ensure brevity in your answer.  0.96. What is the ratio of the Area (% of total land area) of Terrestrial protected areas in 1994 to that in 1997?
Make the answer very short. 0.98. What is the ratio of the Area (% of total land area) of Arable land in 1994 to that in 1997?
Your answer should be very brief. 1.03. What is the ratio of the Area (% of total land area) in Terrestrial protected areas in 1995 to that in 1996?
Ensure brevity in your answer.  0.99. What is the ratio of the Area (% of total land area) of Agricultural land in 1995 to that in 1996?
Give a very brief answer. 0.98. What is the ratio of the Area (% of total land area) in Arable land in 1995 to that in 1996?
Your response must be concise. 1. What is the ratio of the Area (% of total land area) of Terrestrial protected areas in 1995 to that in 1997?
Make the answer very short. 0.98. What is the ratio of the Area (% of total land area) of Agricultural land in 1995 to that in 1997?
Your answer should be very brief. 1.02. What is the ratio of the Area (% of total land area) in Arable land in 1995 to that in 1997?
Keep it short and to the point. 1.03. What is the ratio of the Area (% of total land area) in Permanent crop land in 1995 to that in 1997?
Give a very brief answer. 1. What is the ratio of the Area (% of total land area) in Agricultural land in 1996 to that in 1997?
Keep it short and to the point. 1.04. What is the ratio of the Area (% of total land area) in Arable land in 1996 to that in 1997?
Offer a terse response. 1.03. What is the difference between the highest and the second highest Area (% of total land area) of Terrestrial protected areas?
Provide a succinct answer. 0.08. What is the difference between the highest and the second highest Area (% of total land area) of Agricultural land?
Offer a very short reply. 5.17. What is the difference between the highest and the second highest Area (% of total land area) in Arable land?
Your response must be concise. 2.76. What is the difference between the highest and the lowest Area (% of total land area) of Terrestrial protected areas?
Offer a terse response. 1.04. What is the difference between the highest and the lowest Area (% of total land area) in Agricultural land?
Provide a succinct answer. 7.76. What is the difference between the highest and the lowest Area (% of total land area) in Arable land?
Provide a succinct answer. 4.88. What is the difference between the highest and the lowest Area (% of total land area) of Permanent crop land?
Give a very brief answer. 0.02. 